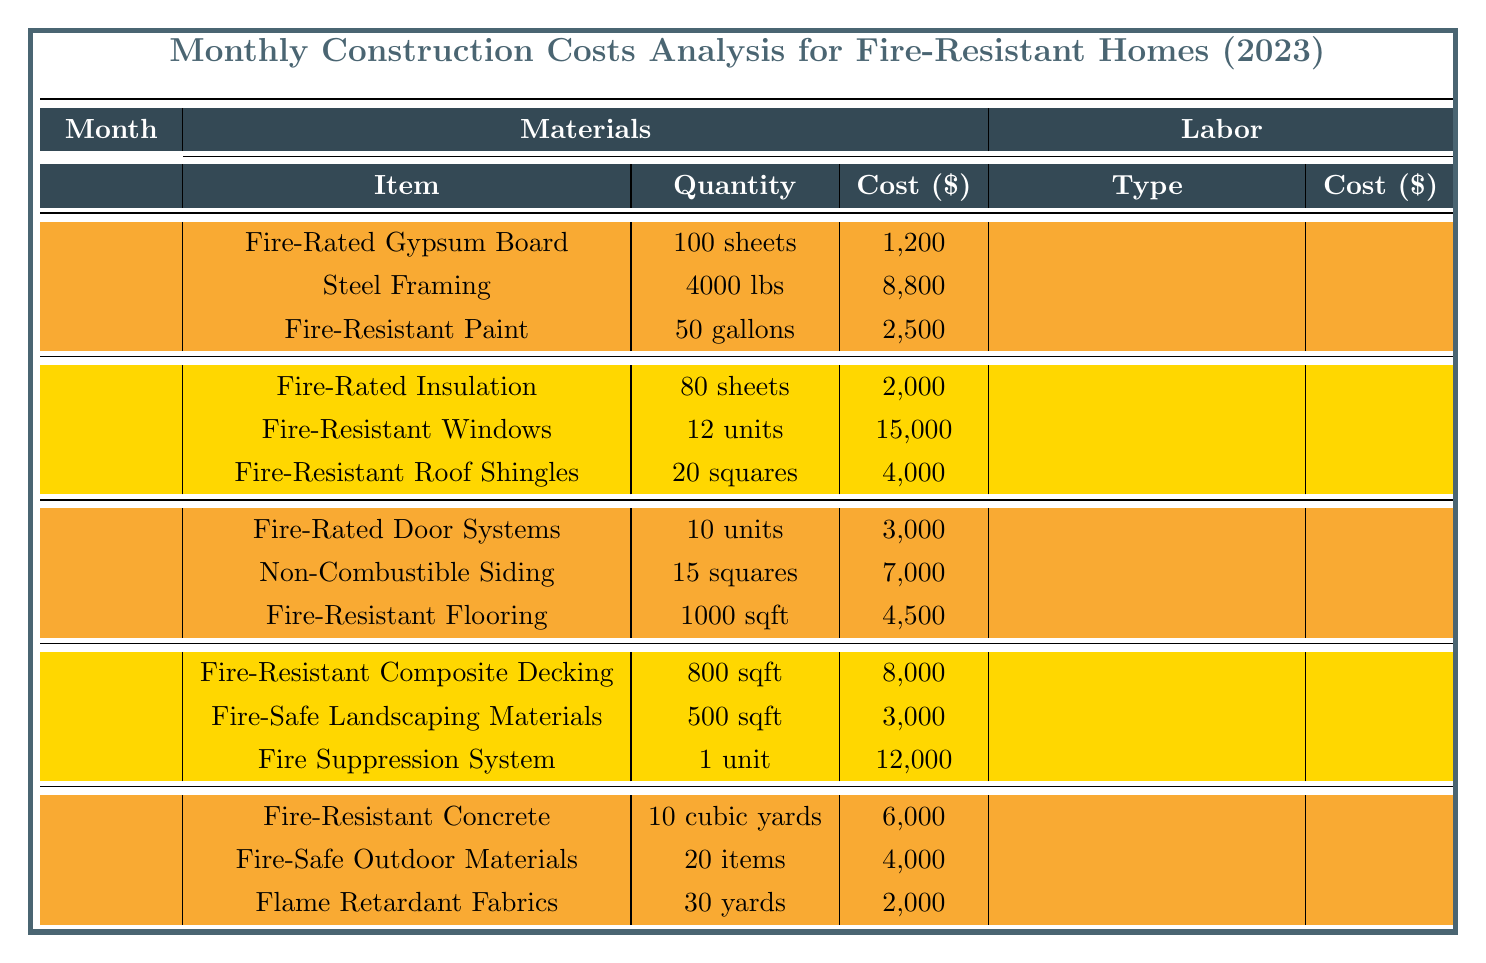What is the total cost for January? The total cost for January is provided at the bottom of the January section in the table as 22,500.
Answer: 22,500 Which month had the highest cost in labor? Looking at the labor costs for each month, February has the highest labor cost at 5,500. This value is obtained by adding the costs for Safety Inspectors (2,500) and Roofing Specialists (3,000).
Answer: February How many units of Fire-resistant windows were purchased in February? The table indicates that 12 units of Fire-Resistant Windows were purchased in February.
Answer: 12 units What is the total cost for materials in March? The total cost for materials in March is found by summing the costs of each material: Fire-Rated Door Systems (3,000), Non-Combustible Siding (7,000), and Fire-Resistant Flooring (4,500). This totals to 3,000 + 7,000 + 4,500 = 14,500.
Answer: 14,500 What percentage of the total cost for April is attributed to the Fire-Safe Landscaping Materials? The total cost for April is 32,000 and the cost for Fire-Safe Landscaping Materials is 3,000. To find the percentage, (3,000 / 32,000) * 100 = 9.375%.
Answer: 9.375% Which month had lower total costs, January or March? January has a total cost of 22,500 while March has a total cost of 22,000. Since 22,000 is less than 22,500, March has lower total costs.
Answer: March What is the average cost of materials in May? In May, the total cost for materials is calculated by adding Fire-Resistant Concrete (6,000), Fire-Safe Outdoor Materials (4,000), and Flame Retardant Fabrics (2,000), which totals 12,000. There are 3 materials, so the average cost is 12,000 / 3 = 4,000.
Answer: 4,000 Was the total monthly cost for January greater than the total monthly cost for February? January has a total cost of 22,500, while February has a total cost of 35,000. Since 22,500 is less than 35,000, the statement is false.
Answer: No If we sum all labor costs across all months, what is the total? The labor costs across the months are: January (5,000), February (5,500), March (7,500), April (7,000), and May (5,500). Adding these values gives 5,000 + 5,500 + 7,500 + 7,000 + 5,500 = 30,500.
Answer: 30,500 What was the cost of Fire-Resistant Paint compared to the Fire-Rated Insulation? The cost of Fire-Resistant Paint in January is 2,500 while Fire-Rated Insulation in February is 2,000. Since 2,500 is greater than 2,000, the cost of Fire-Resistant Paint is higher.
Answer: Higher 